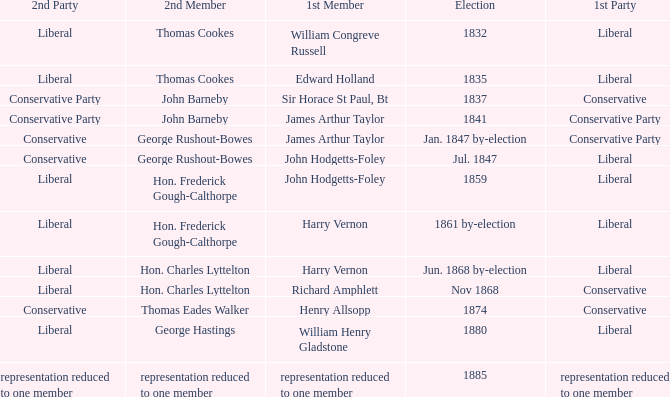What was the 2nd Party that had the 2nd Member John Barneby, when the 1st Party was Conservative? Conservative Party. 